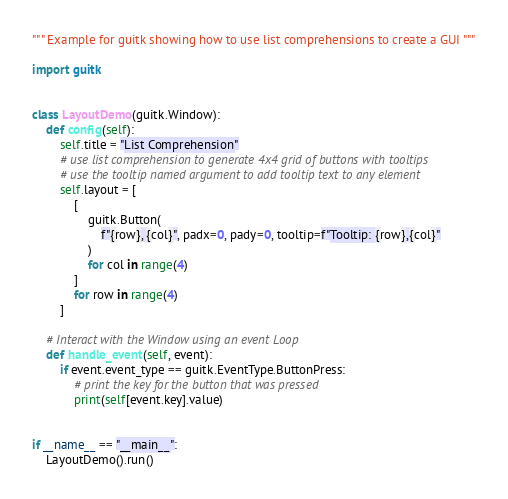<code> <loc_0><loc_0><loc_500><loc_500><_Python_>""" Example for guitk showing how to use list comprehensions to create a GUI """

import guitk


class LayoutDemo(guitk.Window):
    def config(self):
        self.title = "List Comprehension"
        # use list comprehension to generate 4x4 grid of buttons with tooltips
        # use the tooltip named argument to add tooltip text to any element
        self.layout = [
            [
                guitk.Button(
                    f"{row}, {col}", padx=0, pady=0, tooltip=f"Tooltip: {row},{col}"
                )
                for col in range(4)
            ]
            for row in range(4)
        ]

    # Interact with the Window using an event Loop
    def handle_event(self, event):
        if event.event_type == guitk.EventType.ButtonPress:
            # print the key for the button that was pressed
            print(self[event.key].value)


if __name__ == "__main__":
    LayoutDemo().run()
</code> 